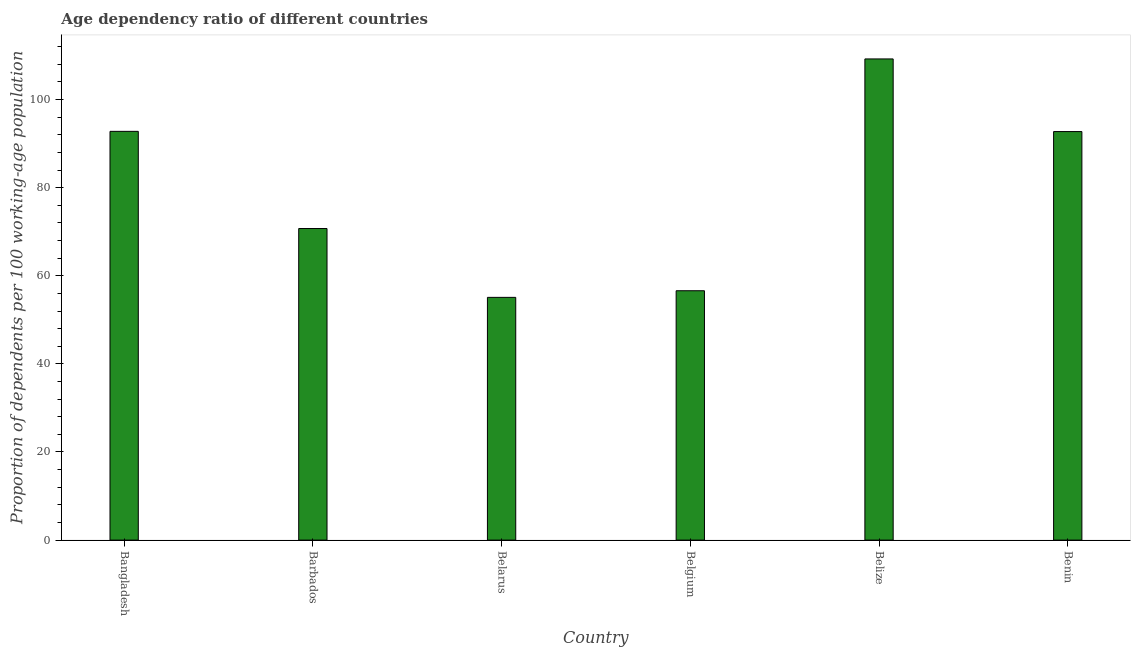Does the graph contain grids?
Ensure brevity in your answer.  No. What is the title of the graph?
Your answer should be very brief. Age dependency ratio of different countries. What is the label or title of the X-axis?
Offer a terse response. Country. What is the label or title of the Y-axis?
Provide a succinct answer. Proportion of dependents per 100 working-age population. What is the age dependency ratio in Benin?
Provide a succinct answer. 92.74. Across all countries, what is the maximum age dependency ratio?
Your answer should be very brief. 109.23. Across all countries, what is the minimum age dependency ratio?
Your answer should be compact. 55.1. In which country was the age dependency ratio maximum?
Keep it short and to the point. Belize. In which country was the age dependency ratio minimum?
Provide a succinct answer. Belarus. What is the sum of the age dependency ratio?
Provide a succinct answer. 477.21. What is the difference between the age dependency ratio in Belarus and Belgium?
Provide a short and direct response. -1.51. What is the average age dependency ratio per country?
Your answer should be very brief. 79.53. What is the median age dependency ratio?
Give a very brief answer. 81.74. What is the ratio of the age dependency ratio in Barbados to that in Belgium?
Provide a short and direct response. 1.25. What is the difference between the highest and the second highest age dependency ratio?
Provide a succinct answer. 16.44. What is the difference between the highest and the lowest age dependency ratio?
Your answer should be compact. 54.13. How many bars are there?
Keep it short and to the point. 6. Are all the bars in the graph horizontal?
Offer a terse response. No. How many countries are there in the graph?
Give a very brief answer. 6. Are the values on the major ticks of Y-axis written in scientific E-notation?
Your answer should be very brief. No. What is the Proportion of dependents per 100 working-age population of Bangladesh?
Keep it short and to the point. 92.79. What is the Proportion of dependents per 100 working-age population in Barbados?
Provide a succinct answer. 70.73. What is the Proportion of dependents per 100 working-age population in Belarus?
Your answer should be compact. 55.1. What is the Proportion of dependents per 100 working-age population of Belgium?
Your answer should be compact. 56.61. What is the Proportion of dependents per 100 working-age population in Belize?
Provide a short and direct response. 109.23. What is the Proportion of dependents per 100 working-age population in Benin?
Your answer should be very brief. 92.74. What is the difference between the Proportion of dependents per 100 working-age population in Bangladesh and Barbados?
Your answer should be very brief. 22.06. What is the difference between the Proportion of dependents per 100 working-age population in Bangladesh and Belarus?
Provide a succinct answer. 37.69. What is the difference between the Proportion of dependents per 100 working-age population in Bangladesh and Belgium?
Provide a short and direct response. 36.18. What is the difference between the Proportion of dependents per 100 working-age population in Bangladesh and Belize?
Offer a very short reply. -16.44. What is the difference between the Proportion of dependents per 100 working-age population in Bangladesh and Benin?
Offer a very short reply. 0.05. What is the difference between the Proportion of dependents per 100 working-age population in Barbados and Belarus?
Your response must be concise. 15.63. What is the difference between the Proportion of dependents per 100 working-age population in Barbados and Belgium?
Your answer should be compact. 14.12. What is the difference between the Proportion of dependents per 100 working-age population in Barbados and Belize?
Ensure brevity in your answer.  -38.5. What is the difference between the Proportion of dependents per 100 working-age population in Barbados and Benin?
Your response must be concise. -22.01. What is the difference between the Proportion of dependents per 100 working-age population in Belarus and Belgium?
Provide a short and direct response. -1.51. What is the difference between the Proportion of dependents per 100 working-age population in Belarus and Belize?
Give a very brief answer. -54.13. What is the difference between the Proportion of dependents per 100 working-age population in Belarus and Benin?
Keep it short and to the point. -37.64. What is the difference between the Proportion of dependents per 100 working-age population in Belgium and Belize?
Your response must be concise. -52.62. What is the difference between the Proportion of dependents per 100 working-age population in Belgium and Benin?
Offer a terse response. -36.13. What is the difference between the Proportion of dependents per 100 working-age population in Belize and Benin?
Give a very brief answer. 16.49. What is the ratio of the Proportion of dependents per 100 working-age population in Bangladesh to that in Barbados?
Your answer should be compact. 1.31. What is the ratio of the Proportion of dependents per 100 working-age population in Bangladesh to that in Belarus?
Your answer should be compact. 1.68. What is the ratio of the Proportion of dependents per 100 working-age population in Bangladesh to that in Belgium?
Offer a terse response. 1.64. What is the ratio of the Proportion of dependents per 100 working-age population in Bangladesh to that in Belize?
Provide a succinct answer. 0.85. What is the ratio of the Proportion of dependents per 100 working-age population in Bangladesh to that in Benin?
Provide a succinct answer. 1. What is the ratio of the Proportion of dependents per 100 working-age population in Barbados to that in Belarus?
Provide a succinct answer. 1.28. What is the ratio of the Proportion of dependents per 100 working-age population in Barbados to that in Belgium?
Your answer should be very brief. 1.25. What is the ratio of the Proportion of dependents per 100 working-age population in Barbados to that in Belize?
Your answer should be compact. 0.65. What is the ratio of the Proportion of dependents per 100 working-age population in Barbados to that in Benin?
Your answer should be very brief. 0.76. What is the ratio of the Proportion of dependents per 100 working-age population in Belarus to that in Belize?
Offer a terse response. 0.5. What is the ratio of the Proportion of dependents per 100 working-age population in Belarus to that in Benin?
Your answer should be very brief. 0.59. What is the ratio of the Proportion of dependents per 100 working-age population in Belgium to that in Belize?
Make the answer very short. 0.52. What is the ratio of the Proportion of dependents per 100 working-age population in Belgium to that in Benin?
Your answer should be compact. 0.61. What is the ratio of the Proportion of dependents per 100 working-age population in Belize to that in Benin?
Provide a short and direct response. 1.18. 